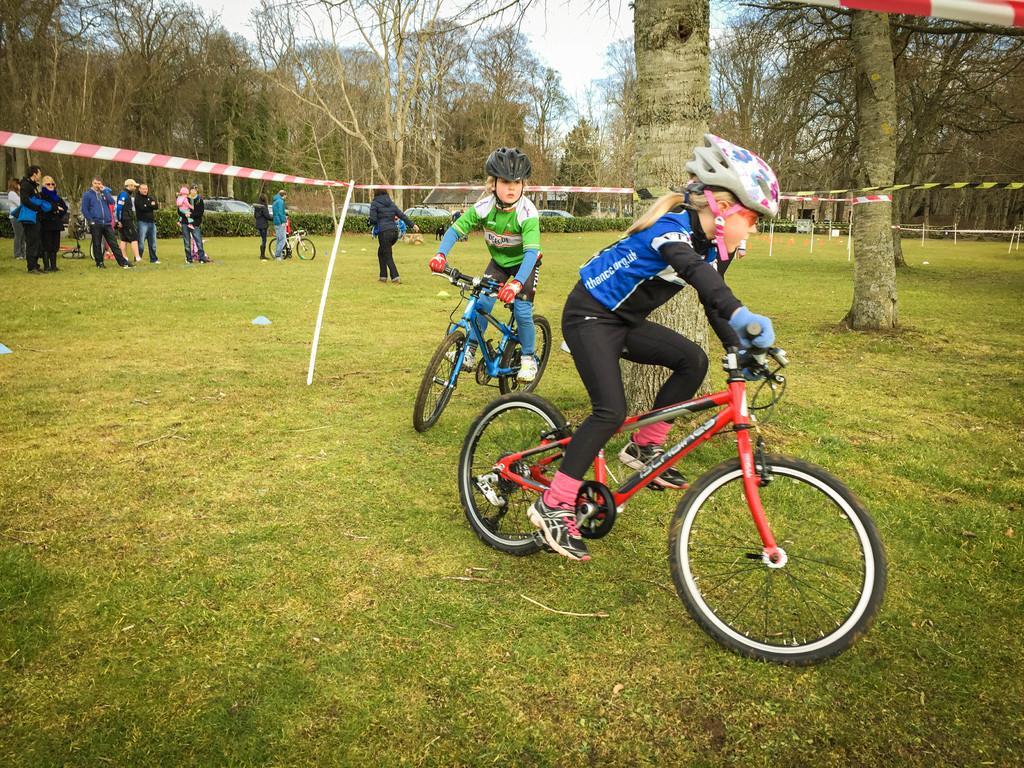In one or two sentences, can you explain what this image depicts? In this image we can see few children riding bicycles and there are some people on the left side of the image and we can see grass on the ground. There are some trees and we can see some vehicles in the background and at the top we can see the sky. 